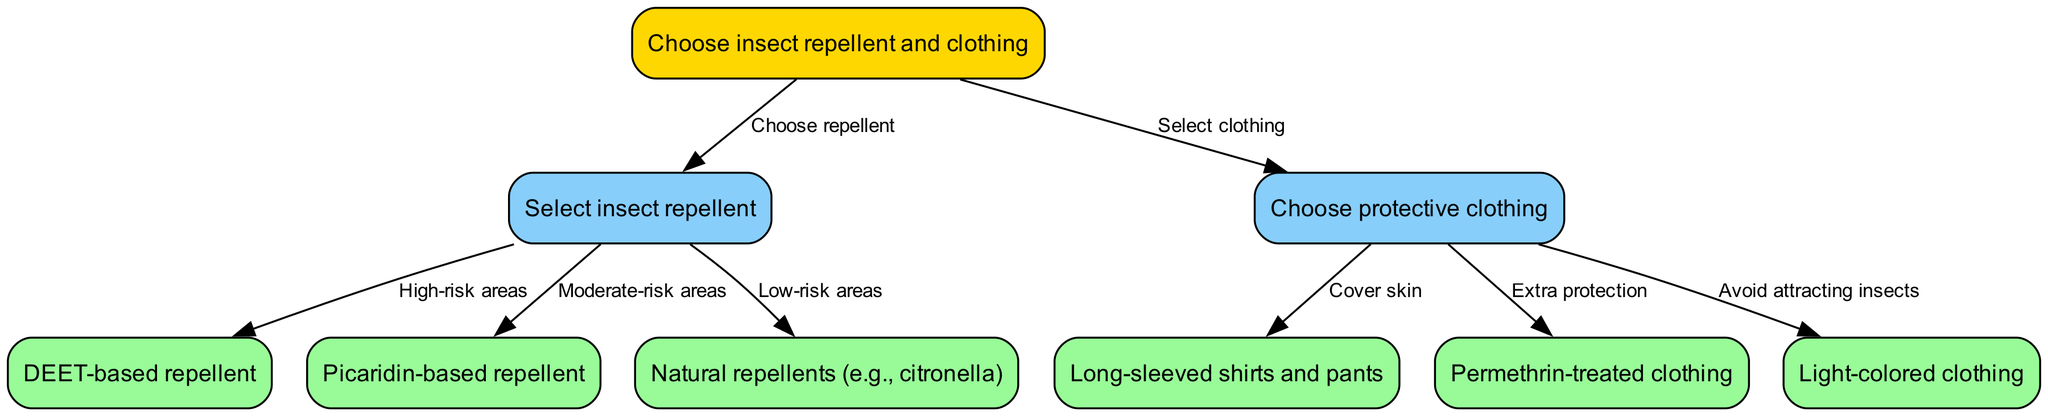What is the starting point of this decision tree? The starting point is labeled "Choose insect repellent and clothing", as indicated by the node labeled "start" in the diagram.
Answer: Choose insect repellent and clothing How many nodes are present in the diagram? Counting the nodes listed in the data, there are 8 nodes in total: start, repellent, clothing, deet, picaridin, natural, longSleeves, permethrin, and lightColors.
Answer: 8 What type of repellent is suggested for high-risk areas? The node connected to high-risk areas mentions "DEET-based repellent", indicating that this is the appropriate choice.
Answer: DEET-based repellent Which clothing option is indicated if you want to cover skin? The option that addresses skin coverage is the node labeled "Long-sleeved shirts and pants".
Answer: Long-sleeved shirts and pants If someone is traveling to moderate-risk areas, which repellent should they choose? The node labeled "Moderate-risk areas" leads to "Picaridin-based repellent", indicating this is the recommended choice for those areas.
Answer: Picaridin-based repellent What is the relationship between "Choose protective clothing" and "Light-colored clothing"? The edge from "Choose protective clothing" to "Light-colored clothing" suggests that light-colored clothing is a choice based on the criterion to avoid attracting insects.
Answer: Avoid attracting insects What additional protection is suggested through clothing selection? The option that provides extra protection is indicated by the node labeled "Permethrin-treated clothing".
Answer: Permethrin-treated clothing How would one navigate to the "Natural repellents" option from the start? From the "start" node, you would choose "Select insect repellent", which then offers three options, leading to "Natural repellents" if you choose low-risk areas.
Answer: By selecting low-risk areas after choosing repellent What is a possible outcome when selecting "DEET-based repellent"? The selection of "DEET-based repellent" implies a choice made for high-risk areas which represents a response to the decision flow from that node.
Answer: High-risk areas 